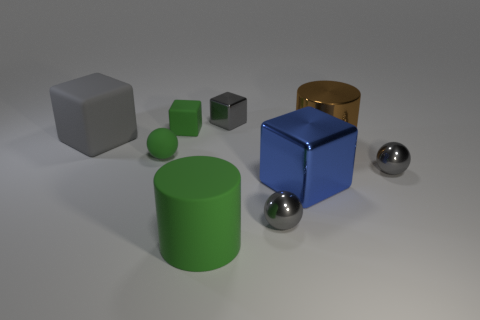Add 1 blue matte spheres. How many objects exist? 10 Subtract all cylinders. How many objects are left? 7 Subtract all tiny purple matte cylinders. Subtract all metal balls. How many objects are left? 7 Add 4 brown objects. How many brown objects are left? 5 Add 4 small gray metallic things. How many small gray metallic things exist? 7 Subtract 0 yellow balls. How many objects are left? 9 